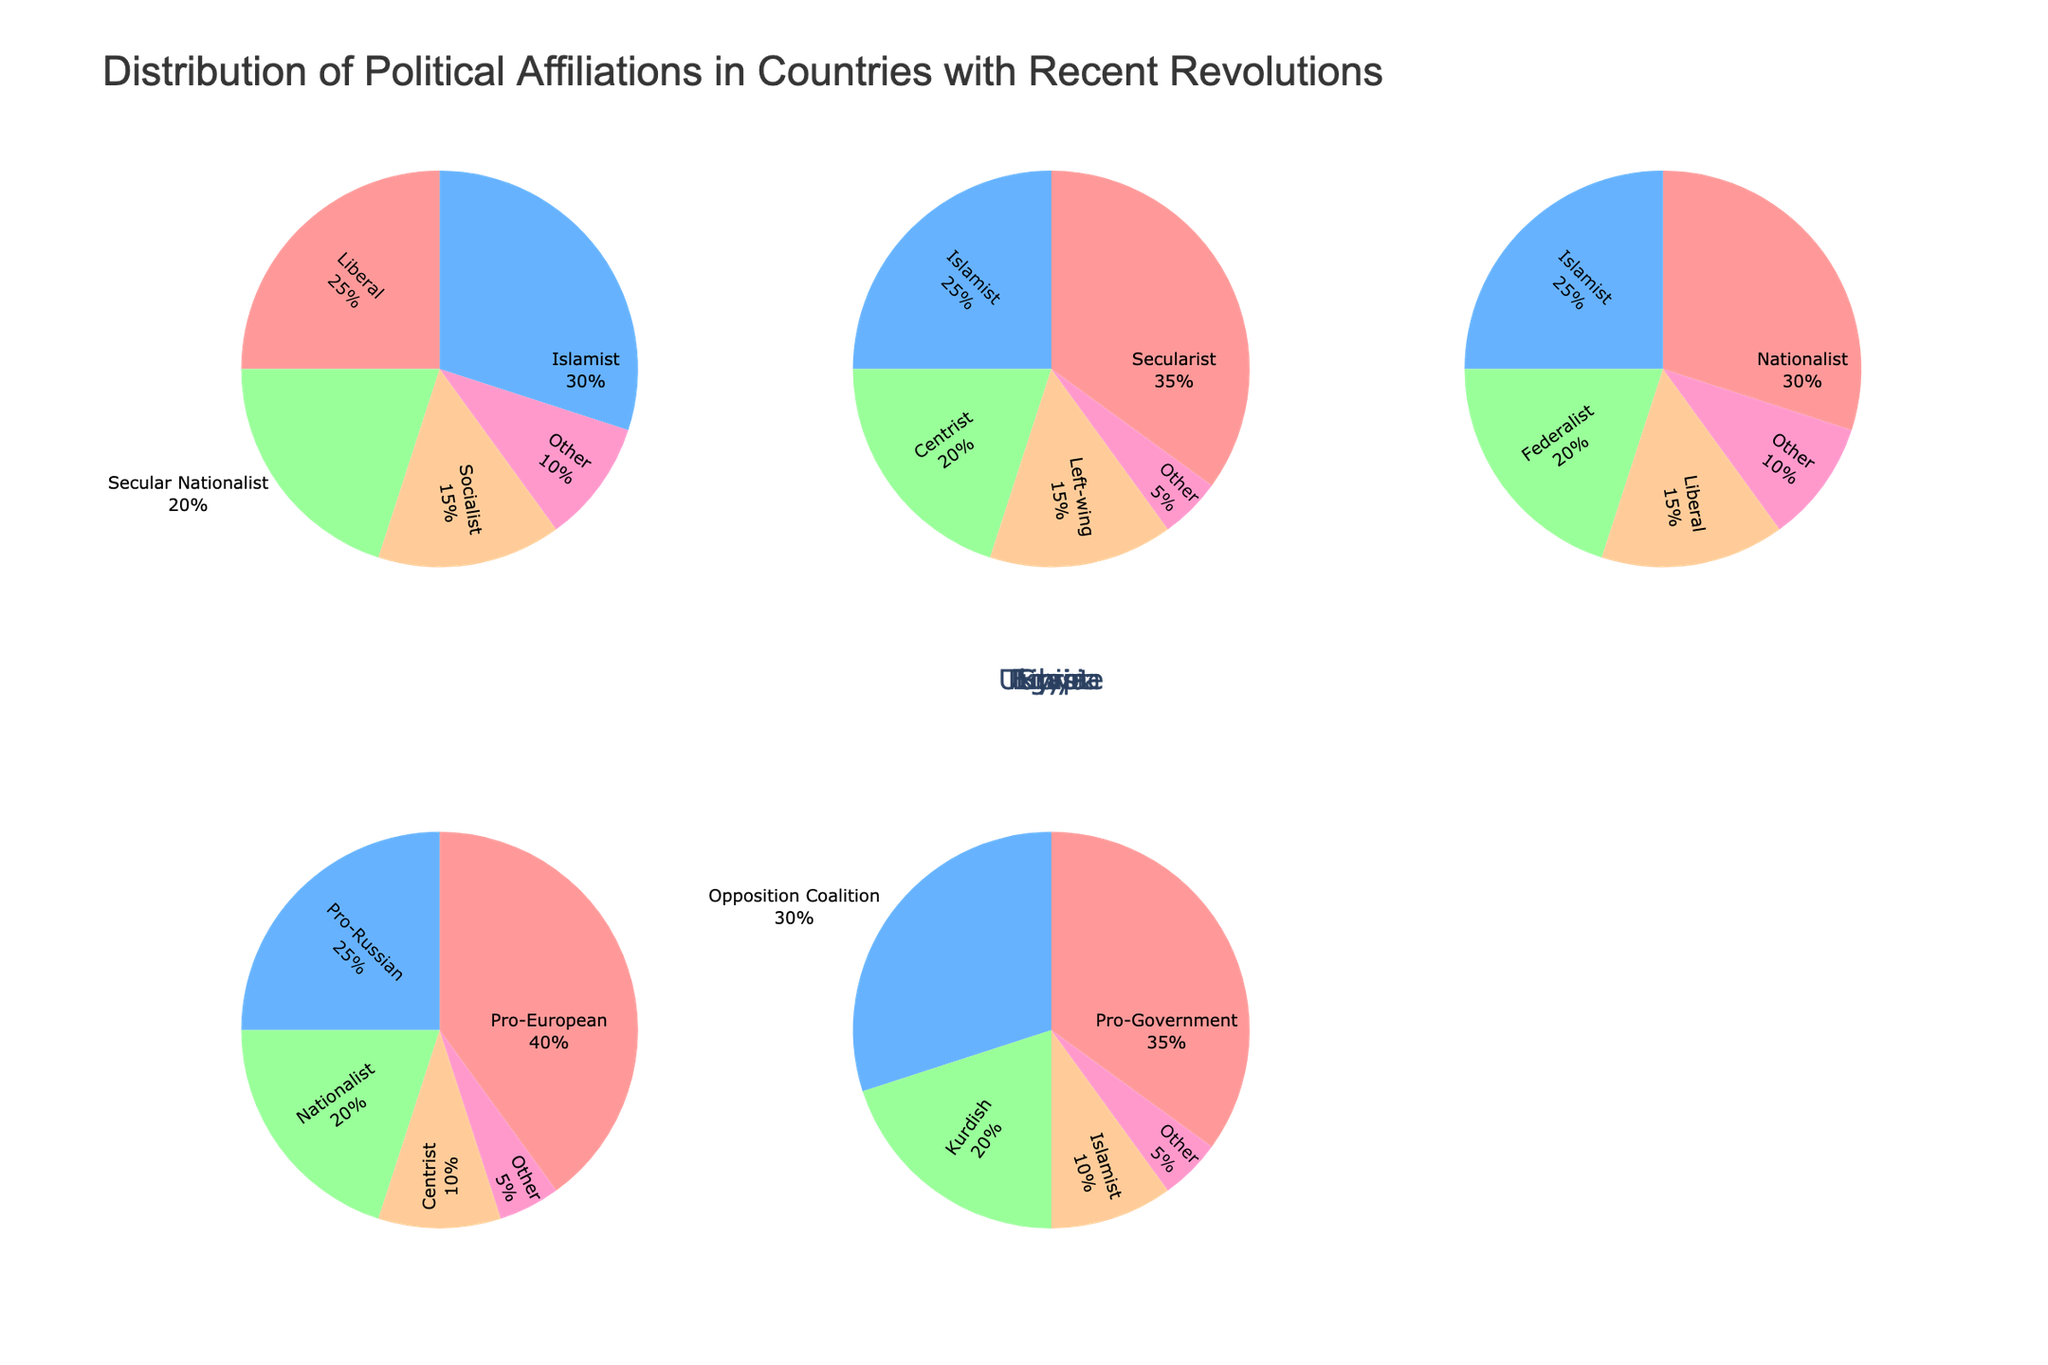What's the predominant political affiliation in Egypt? The figure shows that the Islamist sector occupies the largest portion of the pie with 30%, compared to other affiliations.
Answer: Islamist Which country has the highest percentage of one political affiliation, and what is it? By examining the percentages in each country's pie chart, Ukraine's Pro-European affiliation stands out with 40%, the highest single category percentage among all countries represented.
Answer: Ukraine, Pro-European Compare the percentage of Socialist affiliation in Egypt with Left-wing affiliation in Tunisia. Which is greater? The pie chart shows that Socialist in Egypt is 15% and Left-wing in Tunisia is also 15%. Therefore, they are equal.
Answer: Equal What's the total percentage of non-mainstream (Other category) political affiliations across all countries? The Other category in each country is: Egypt 10%, Tunisia 5%, Libya 10%, Ukraine 5%, Syria 5%. Summing these gives us 10 + 5 + 10 + 5 + 5 = 35%
Answer: 35% If you add the Islamist percentage in Egypt to the Islamist percentage in Libya, what is the total? Islamist in Egypt is 30% and in Libya, it is 25%. Adding these together: 30 + 25 = 55%
Answer: 55% Which country has the smallest Other category and what is the percentage? The figure shows that Tunisia’s Other category is the smallest at 5%.
Answer: Tunisia, 5% How do the percentage values for the Secularist category in Tunisia compare with the Nationalist category in Libya? The Secularist percentage in Tunisia is 35%, whereas the Nationalist percentage in Libya is 30%. Therefore, the Secularist in Tunisia is 5% higher than the Nationalist in Libya.
Answer: Secularist in Tunisia is greater by 5% What is the difference in percentage between the Pro-Government and Opposition Coalition in Syria? Pro-Government in Syria is 35% and Opposition Coalition is 30%. The difference is 35 - 30 = 5%
Answer: 5% Which political affiliation in Ukraine is the second largest and what is its percentage? The Pro-European category is the largest with 40%, followed by Pro-Russian with 25%.
Answer: Pro-Russian, 25% Combine the Centrist categories from Tunisia and Ukraine. What’s their total percentage? Centrist in Tunisia is 20% and Centrist in Ukraine is 10%. Summing these together: 20 + 10 = 30%
Answer: 30% 